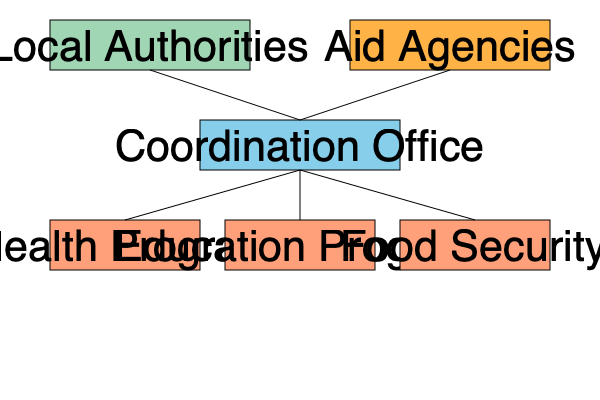Based on the organizational chart, which entity serves as the central point of coordination between local authorities, aid agencies, and program teams? To answer this question, let's analyze the organizational chart step-by-step:

1. At the top level, we see two main entities: Local Authorities and Aid Agencies.

2. Both Local Authorities and Aid Agencies have lines connecting them to a central box labeled "Coordination Office."

3. The Coordination Office, in turn, has lines connecting it to three program teams: Health Program, Education Program, and Food Security.

4. This structure indicates that the Coordination Office sits between the top-level entities (Local Authorities and Aid Agencies) and the program implementation teams.

5. The position of the Coordination Office in the chart suggests that it acts as an intermediary, facilitating communication and coordination between the various stakeholders.

6. Its central position allows it to receive input from both Local Authorities and Aid Agencies, and then disseminate information and instructions to the program teams.

7. This structure is typical in aid program implementation, where a central coordinating body ensures that local needs (represented by Local Authorities) and aid resources (represented by Aid Agencies) are effectively aligned with on-the-ground programs.

Therefore, based on its position and connections in the organizational chart, the Coordination Office serves as the central point of coordination between local authorities, aid agencies, and program teams.
Answer: Coordination Office 